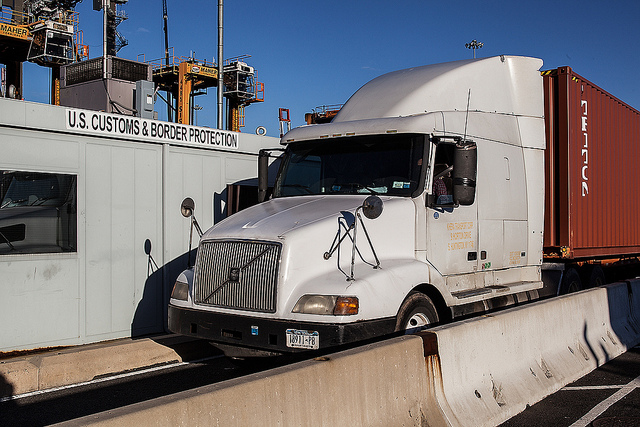What role do technology and equipment play at this inspection booth? Technological tools and equipment at border inspection booths, such as the one pictured, are vital for enhancing efficiency and effectiveness. These may include scanning systems for detecting contraband, databases for checking documentation swiftly, and communication devices for coordinating with other border agents. The presence of robust technological tools helps in a thorough yet efficient inspection process. 